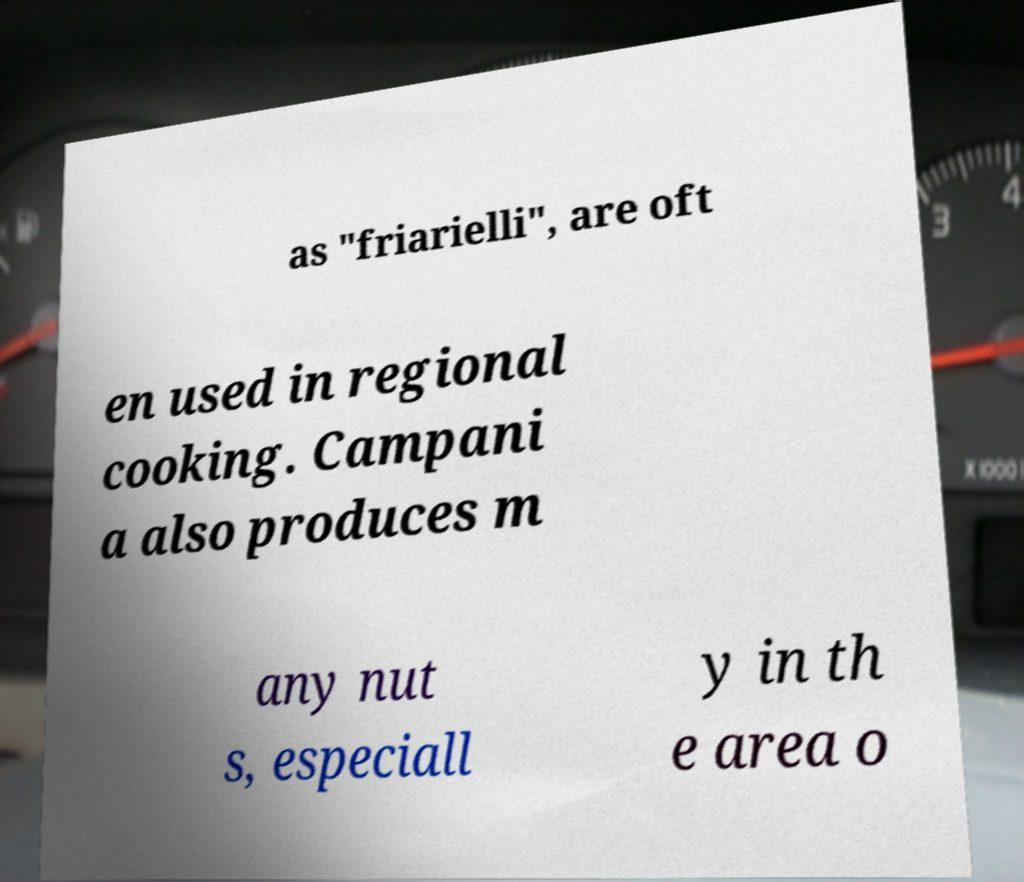Could you extract and type out the text from this image? as "friarielli", are oft en used in regional cooking. Campani a also produces m any nut s, especiall y in th e area o 